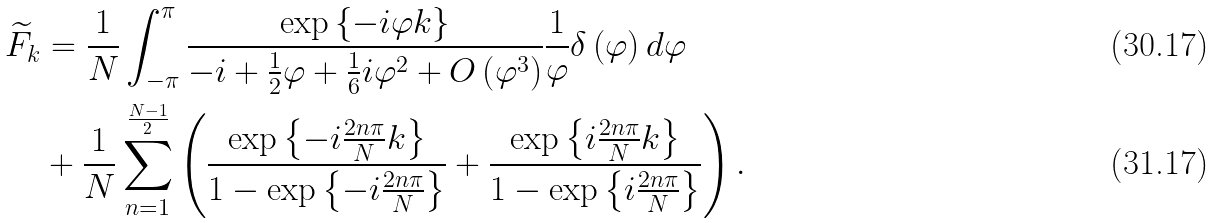Convert formula to latex. <formula><loc_0><loc_0><loc_500><loc_500>\widetilde { F } _ { k } & = \frac { 1 } { N } \int _ { - \pi } ^ { \pi } \frac { \exp \left \{ - i \varphi k \right \} } { - i + \frac { 1 } { 2 } \varphi + \frac { 1 } { 6 } i \varphi ^ { 2 } + O \left ( \varphi ^ { 3 } \right ) } \frac { 1 } { \varphi } \delta \left ( \varphi \right ) d \varphi \\ & + \frac { 1 } { N } \sum _ { n = 1 } ^ { \frac { N - 1 } { 2 } } \left ( \frac { \exp \left \{ - i \frac { 2 n \pi } { N } k \right \} } { 1 - \exp \left \{ - i \frac { 2 n \pi } { N } \right \} } + \frac { \exp \left \{ i \frac { 2 n \pi } { N } k \right \} } { 1 - \exp \left \{ i \frac { 2 n \pi } { N } \right \} } \right ) .</formula> 